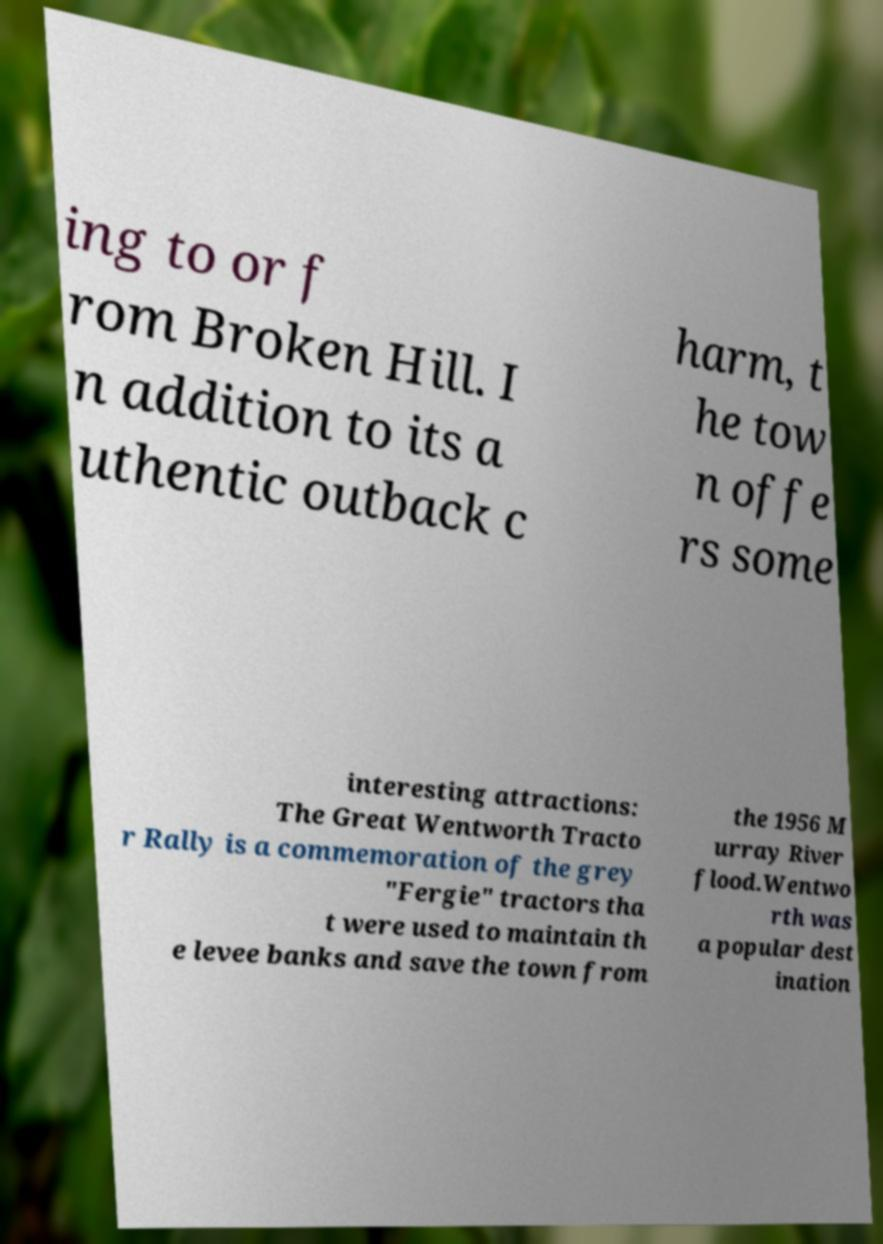I need the written content from this picture converted into text. Can you do that? ing to or f rom Broken Hill. I n addition to its a uthentic outback c harm, t he tow n offe rs some interesting attractions: The Great Wentworth Tracto r Rally is a commemoration of the grey "Fergie" tractors tha t were used to maintain th e levee banks and save the town from the 1956 M urray River flood.Wentwo rth was a popular dest ination 